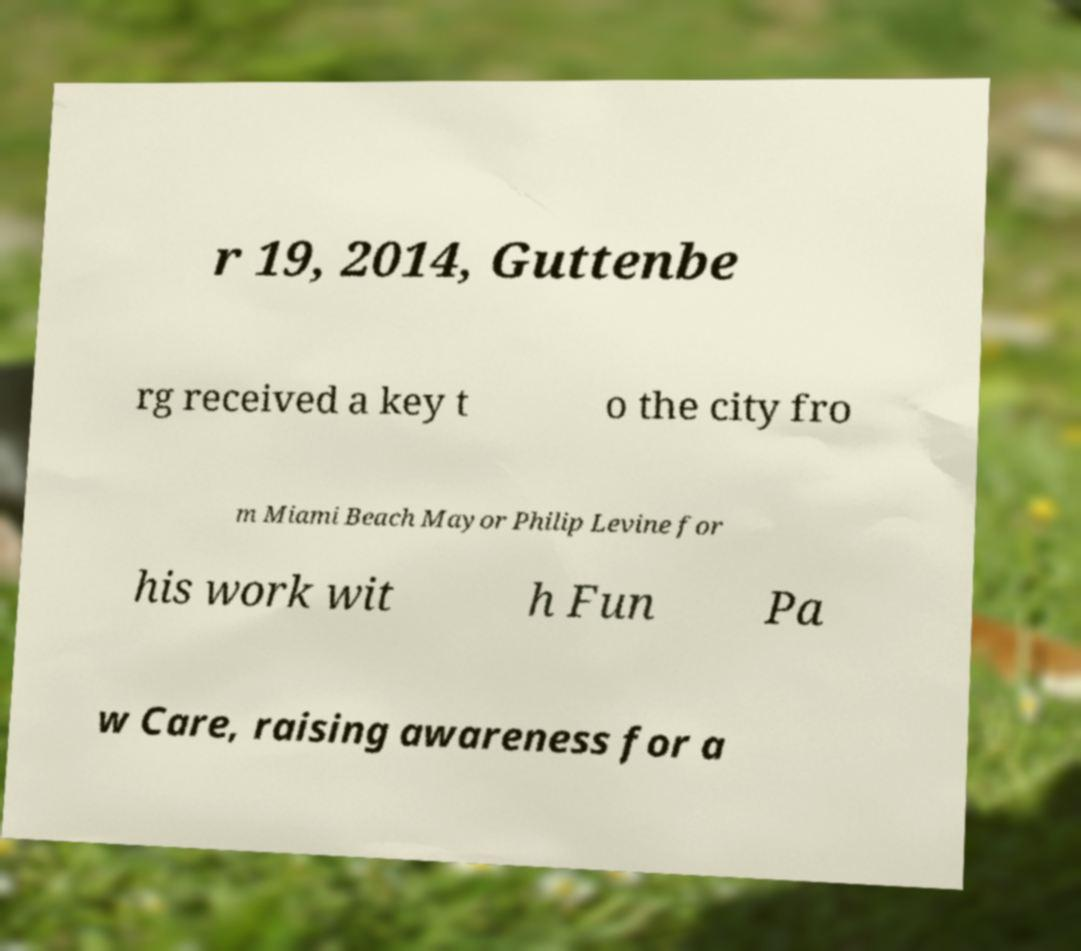Please identify and transcribe the text found in this image. r 19, 2014, Guttenbe rg received a key t o the city fro m Miami Beach Mayor Philip Levine for his work wit h Fun Pa w Care, raising awareness for a 